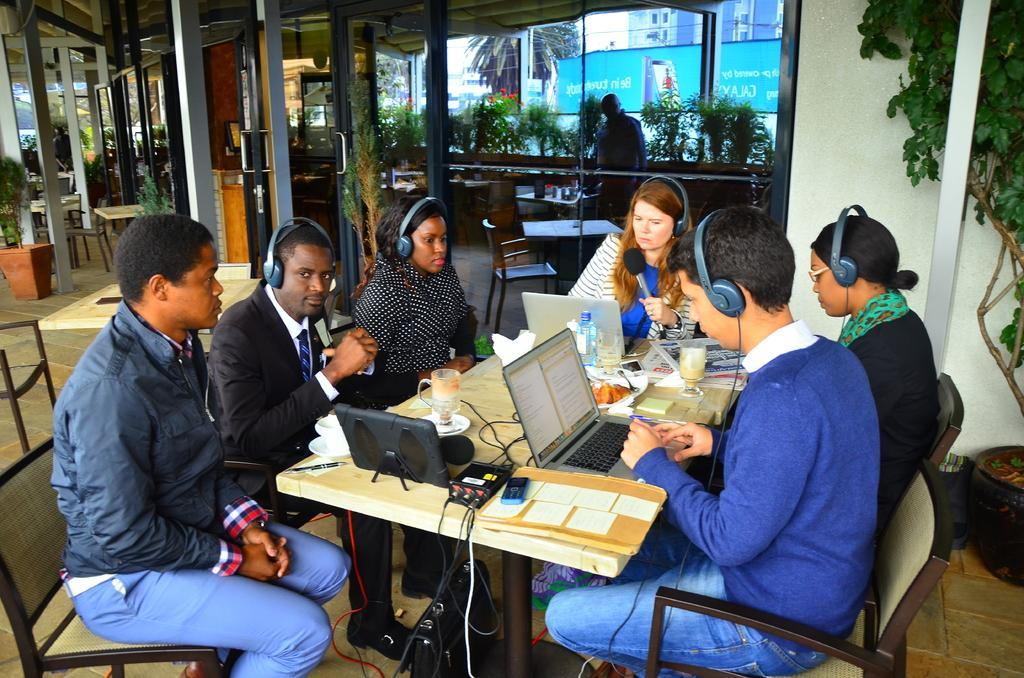How many people are in the image? There is a group of people in the image. What are the people doing in the image? The people are sitting on chairs. Where are the chairs located in relation to the table? The chairs are in front of a table. What electronic devices are on the table? There are laptops on the table. What type of beverage container is on the table? There is a water bottle on the table. What other objects can be seen on the table? There are other objects on the table. What type of linen is draped over the laptops on the table? There is no linen present in the image; the laptops are not covered by any fabric. 